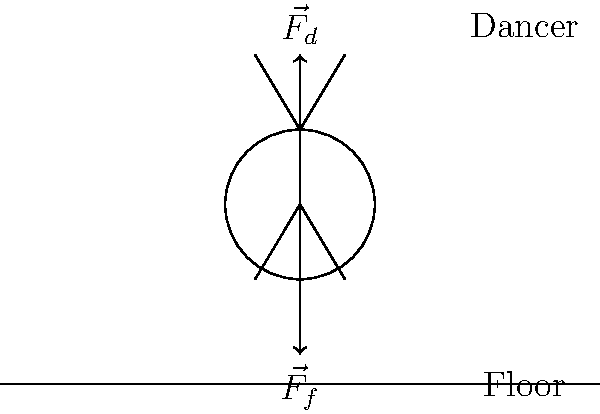In a dance performance, a dancer pushes down on the floor with a force $\vec{F}_d$. According to Newton's Third Law, what is the magnitude and direction of the force $\vec{F}_f$ exerted by the floor on the dancer? To answer this question, we need to apply Newton's Third Law of Motion and understand the concept of action-reaction pairs. Let's break it down step-by-step:

1. Newton's Third Law states that for every action, there is an equal and opposite reaction.

2. In this scenario:
   - The action is the dancer pushing down on the floor with force $\vec{F}_d$.
   - The reaction is the floor pushing back on the dancer with force $\vec{F}_f$.

3. According to the law:
   - The magnitude of $\vec{F}_f$ must be equal to the magnitude of $\vec{F}_d$.
   - The direction of $\vec{F}_f$ must be opposite to the direction of $\vec{F}_d$.

4. In the diagram:
   - $\vec{F}_d$ is shown pointing downward (the dancer pushing down).
   - $\vec{F}_f$ is shown pointing upward (the floor pushing up).

5. Therefore:
   - The magnitude of $\vec{F}_f$ is equal to the magnitude of $\vec{F}_d$.
   - The direction of $\vec{F}_f$ is upward, opposite to $\vec{F}_d$.

This interaction between the dancer and the floor is crucial for movements in dance. The upward force from the floor allows the dancer to push off and execute jumps, turns, and other dynamic movements.
Answer: Equal magnitude, opposite direction (upward) 